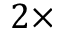<formula> <loc_0><loc_0><loc_500><loc_500>2 \times</formula> 